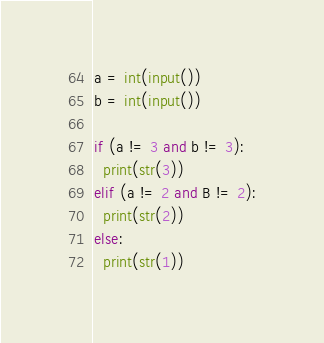<code> <loc_0><loc_0><loc_500><loc_500><_Python_>a = int(input())
b = int(input())
 
if (a != 3 and b != 3):
  print(str(3))
elif (a != 2 and B != 2):
  print(str(2))
else:
  print(str(1))</code> 